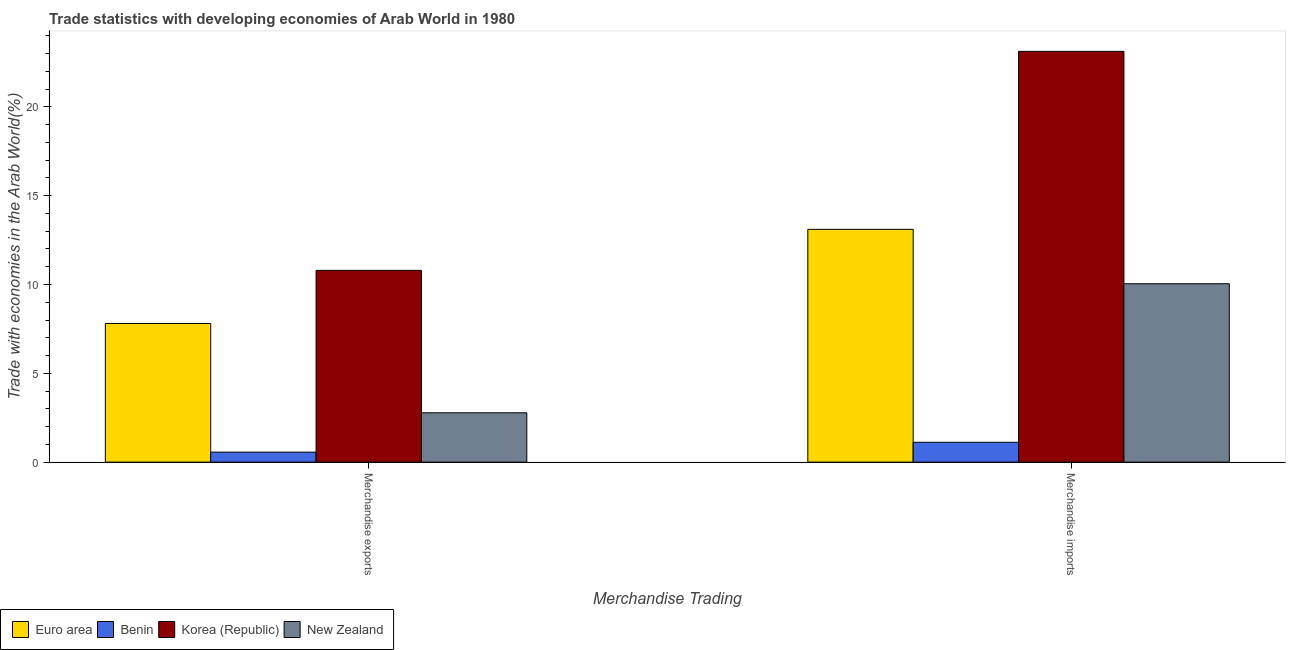How many bars are there on the 2nd tick from the left?
Provide a succinct answer. 4. How many bars are there on the 1st tick from the right?
Make the answer very short. 4. What is the label of the 2nd group of bars from the left?
Give a very brief answer. Merchandise imports. What is the merchandise exports in Euro area?
Offer a terse response. 7.81. Across all countries, what is the maximum merchandise exports?
Provide a short and direct response. 10.8. Across all countries, what is the minimum merchandise imports?
Your answer should be very brief. 1.12. In which country was the merchandise exports maximum?
Offer a terse response. Korea (Republic). In which country was the merchandise exports minimum?
Offer a terse response. Benin. What is the total merchandise imports in the graph?
Your answer should be very brief. 47.39. What is the difference between the merchandise imports in Korea (Republic) and that in Euro area?
Make the answer very short. 10.02. What is the difference between the merchandise imports in Korea (Republic) and the merchandise exports in Euro area?
Keep it short and to the point. 15.32. What is the average merchandise exports per country?
Ensure brevity in your answer.  5.49. What is the difference between the merchandise imports and merchandise exports in New Zealand?
Offer a very short reply. 7.27. In how many countries, is the merchandise imports greater than 10 %?
Your response must be concise. 3. What is the ratio of the merchandise exports in Benin to that in Euro area?
Provide a succinct answer. 0.07. Is the merchandise exports in Benin less than that in New Zealand?
Provide a short and direct response. Yes. What does the 4th bar from the left in Merchandise imports represents?
Provide a short and direct response. New Zealand. What does the 3rd bar from the right in Merchandise imports represents?
Your response must be concise. Benin. Does the graph contain any zero values?
Offer a very short reply. No. How many legend labels are there?
Your response must be concise. 4. How are the legend labels stacked?
Your answer should be compact. Horizontal. What is the title of the graph?
Make the answer very short. Trade statistics with developing economies of Arab World in 1980. Does "Middle East & North Africa (developing only)" appear as one of the legend labels in the graph?
Offer a terse response. No. What is the label or title of the X-axis?
Make the answer very short. Merchandise Trading. What is the label or title of the Y-axis?
Keep it short and to the point. Trade with economies in the Arab World(%). What is the Trade with economies in the Arab World(%) of Euro area in Merchandise exports?
Provide a succinct answer. 7.81. What is the Trade with economies in the Arab World(%) of Benin in Merchandise exports?
Your answer should be very brief. 0.56. What is the Trade with economies in the Arab World(%) of Korea (Republic) in Merchandise exports?
Offer a very short reply. 10.8. What is the Trade with economies in the Arab World(%) of New Zealand in Merchandise exports?
Ensure brevity in your answer.  2.78. What is the Trade with economies in the Arab World(%) of Euro area in Merchandise imports?
Offer a terse response. 13.11. What is the Trade with economies in the Arab World(%) in Benin in Merchandise imports?
Provide a succinct answer. 1.12. What is the Trade with economies in the Arab World(%) of Korea (Republic) in Merchandise imports?
Provide a short and direct response. 23.12. What is the Trade with economies in the Arab World(%) in New Zealand in Merchandise imports?
Provide a short and direct response. 10.04. Across all Merchandise Trading, what is the maximum Trade with economies in the Arab World(%) of Euro area?
Provide a short and direct response. 13.11. Across all Merchandise Trading, what is the maximum Trade with economies in the Arab World(%) in Benin?
Offer a terse response. 1.12. Across all Merchandise Trading, what is the maximum Trade with economies in the Arab World(%) of Korea (Republic)?
Make the answer very short. 23.12. Across all Merchandise Trading, what is the maximum Trade with economies in the Arab World(%) of New Zealand?
Offer a very short reply. 10.04. Across all Merchandise Trading, what is the minimum Trade with economies in the Arab World(%) of Euro area?
Your response must be concise. 7.81. Across all Merchandise Trading, what is the minimum Trade with economies in the Arab World(%) of Benin?
Provide a short and direct response. 0.56. Across all Merchandise Trading, what is the minimum Trade with economies in the Arab World(%) of Korea (Republic)?
Your response must be concise. 10.8. Across all Merchandise Trading, what is the minimum Trade with economies in the Arab World(%) of New Zealand?
Provide a succinct answer. 2.78. What is the total Trade with economies in the Arab World(%) of Euro area in the graph?
Provide a short and direct response. 20.91. What is the total Trade with economies in the Arab World(%) in Benin in the graph?
Offer a very short reply. 1.68. What is the total Trade with economies in the Arab World(%) in Korea (Republic) in the graph?
Provide a succinct answer. 33.92. What is the total Trade with economies in the Arab World(%) of New Zealand in the graph?
Offer a very short reply. 12.82. What is the difference between the Trade with economies in the Arab World(%) of Euro area in Merchandise exports and that in Merchandise imports?
Provide a succinct answer. -5.3. What is the difference between the Trade with economies in the Arab World(%) in Benin in Merchandise exports and that in Merchandise imports?
Keep it short and to the point. -0.56. What is the difference between the Trade with economies in the Arab World(%) of Korea (Republic) in Merchandise exports and that in Merchandise imports?
Offer a terse response. -12.33. What is the difference between the Trade with economies in the Arab World(%) in New Zealand in Merchandise exports and that in Merchandise imports?
Give a very brief answer. -7.26. What is the difference between the Trade with economies in the Arab World(%) of Euro area in Merchandise exports and the Trade with economies in the Arab World(%) of Benin in Merchandise imports?
Ensure brevity in your answer.  6.69. What is the difference between the Trade with economies in the Arab World(%) of Euro area in Merchandise exports and the Trade with economies in the Arab World(%) of Korea (Republic) in Merchandise imports?
Provide a succinct answer. -15.32. What is the difference between the Trade with economies in the Arab World(%) of Euro area in Merchandise exports and the Trade with economies in the Arab World(%) of New Zealand in Merchandise imports?
Your answer should be very brief. -2.24. What is the difference between the Trade with economies in the Arab World(%) in Benin in Merchandise exports and the Trade with economies in the Arab World(%) in Korea (Republic) in Merchandise imports?
Your response must be concise. -22.56. What is the difference between the Trade with economies in the Arab World(%) of Benin in Merchandise exports and the Trade with economies in the Arab World(%) of New Zealand in Merchandise imports?
Ensure brevity in your answer.  -9.48. What is the difference between the Trade with economies in the Arab World(%) of Korea (Republic) in Merchandise exports and the Trade with economies in the Arab World(%) of New Zealand in Merchandise imports?
Your answer should be compact. 0.75. What is the average Trade with economies in the Arab World(%) of Euro area per Merchandise Trading?
Your response must be concise. 10.46. What is the average Trade with economies in the Arab World(%) in Benin per Merchandise Trading?
Your answer should be very brief. 0.84. What is the average Trade with economies in the Arab World(%) of Korea (Republic) per Merchandise Trading?
Provide a short and direct response. 16.96. What is the average Trade with economies in the Arab World(%) in New Zealand per Merchandise Trading?
Ensure brevity in your answer.  6.41. What is the difference between the Trade with economies in the Arab World(%) in Euro area and Trade with economies in the Arab World(%) in Benin in Merchandise exports?
Ensure brevity in your answer.  7.24. What is the difference between the Trade with economies in the Arab World(%) of Euro area and Trade with economies in the Arab World(%) of Korea (Republic) in Merchandise exports?
Your response must be concise. -2.99. What is the difference between the Trade with economies in the Arab World(%) of Euro area and Trade with economies in the Arab World(%) of New Zealand in Merchandise exports?
Offer a very short reply. 5.03. What is the difference between the Trade with economies in the Arab World(%) in Benin and Trade with economies in the Arab World(%) in Korea (Republic) in Merchandise exports?
Ensure brevity in your answer.  -10.23. What is the difference between the Trade with economies in the Arab World(%) of Benin and Trade with economies in the Arab World(%) of New Zealand in Merchandise exports?
Your response must be concise. -2.21. What is the difference between the Trade with economies in the Arab World(%) in Korea (Republic) and Trade with economies in the Arab World(%) in New Zealand in Merchandise exports?
Ensure brevity in your answer.  8.02. What is the difference between the Trade with economies in the Arab World(%) in Euro area and Trade with economies in the Arab World(%) in Benin in Merchandise imports?
Your answer should be compact. 11.99. What is the difference between the Trade with economies in the Arab World(%) of Euro area and Trade with economies in the Arab World(%) of Korea (Republic) in Merchandise imports?
Keep it short and to the point. -10.02. What is the difference between the Trade with economies in the Arab World(%) of Euro area and Trade with economies in the Arab World(%) of New Zealand in Merchandise imports?
Your response must be concise. 3.06. What is the difference between the Trade with economies in the Arab World(%) of Benin and Trade with economies in the Arab World(%) of Korea (Republic) in Merchandise imports?
Make the answer very short. -22.01. What is the difference between the Trade with economies in the Arab World(%) in Benin and Trade with economies in the Arab World(%) in New Zealand in Merchandise imports?
Make the answer very short. -8.92. What is the difference between the Trade with economies in the Arab World(%) in Korea (Republic) and Trade with economies in the Arab World(%) in New Zealand in Merchandise imports?
Provide a succinct answer. 13.08. What is the ratio of the Trade with economies in the Arab World(%) of Euro area in Merchandise exports to that in Merchandise imports?
Provide a succinct answer. 0.6. What is the ratio of the Trade with economies in the Arab World(%) of Benin in Merchandise exports to that in Merchandise imports?
Give a very brief answer. 0.5. What is the ratio of the Trade with economies in the Arab World(%) of Korea (Republic) in Merchandise exports to that in Merchandise imports?
Give a very brief answer. 0.47. What is the ratio of the Trade with economies in the Arab World(%) of New Zealand in Merchandise exports to that in Merchandise imports?
Keep it short and to the point. 0.28. What is the difference between the highest and the second highest Trade with economies in the Arab World(%) of Euro area?
Your answer should be very brief. 5.3. What is the difference between the highest and the second highest Trade with economies in the Arab World(%) of Benin?
Keep it short and to the point. 0.56. What is the difference between the highest and the second highest Trade with economies in the Arab World(%) in Korea (Republic)?
Your response must be concise. 12.33. What is the difference between the highest and the second highest Trade with economies in the Arab World(%) of New Zealand?
Make the answer very short. 7.26. What is the difference between the highest and the lowest Trade with economies in the Arab World(%) in Euro area?
Your answer should be compact. 5.3. What is the difference between the highest and the lowest Trade with economies in the Arab World(%) in Benin?
Provide a short and direct response. 0.56. What is the difference between the highest and the lowest Trade with economies in the Arab World(%) in Korea (Republic)?
Make the answer very short. 12.33. What is the difference between the highest and the lowest Trade with economies in the Arab World(%) in New Zealand?
Provide a succinct answer. 7.26. 